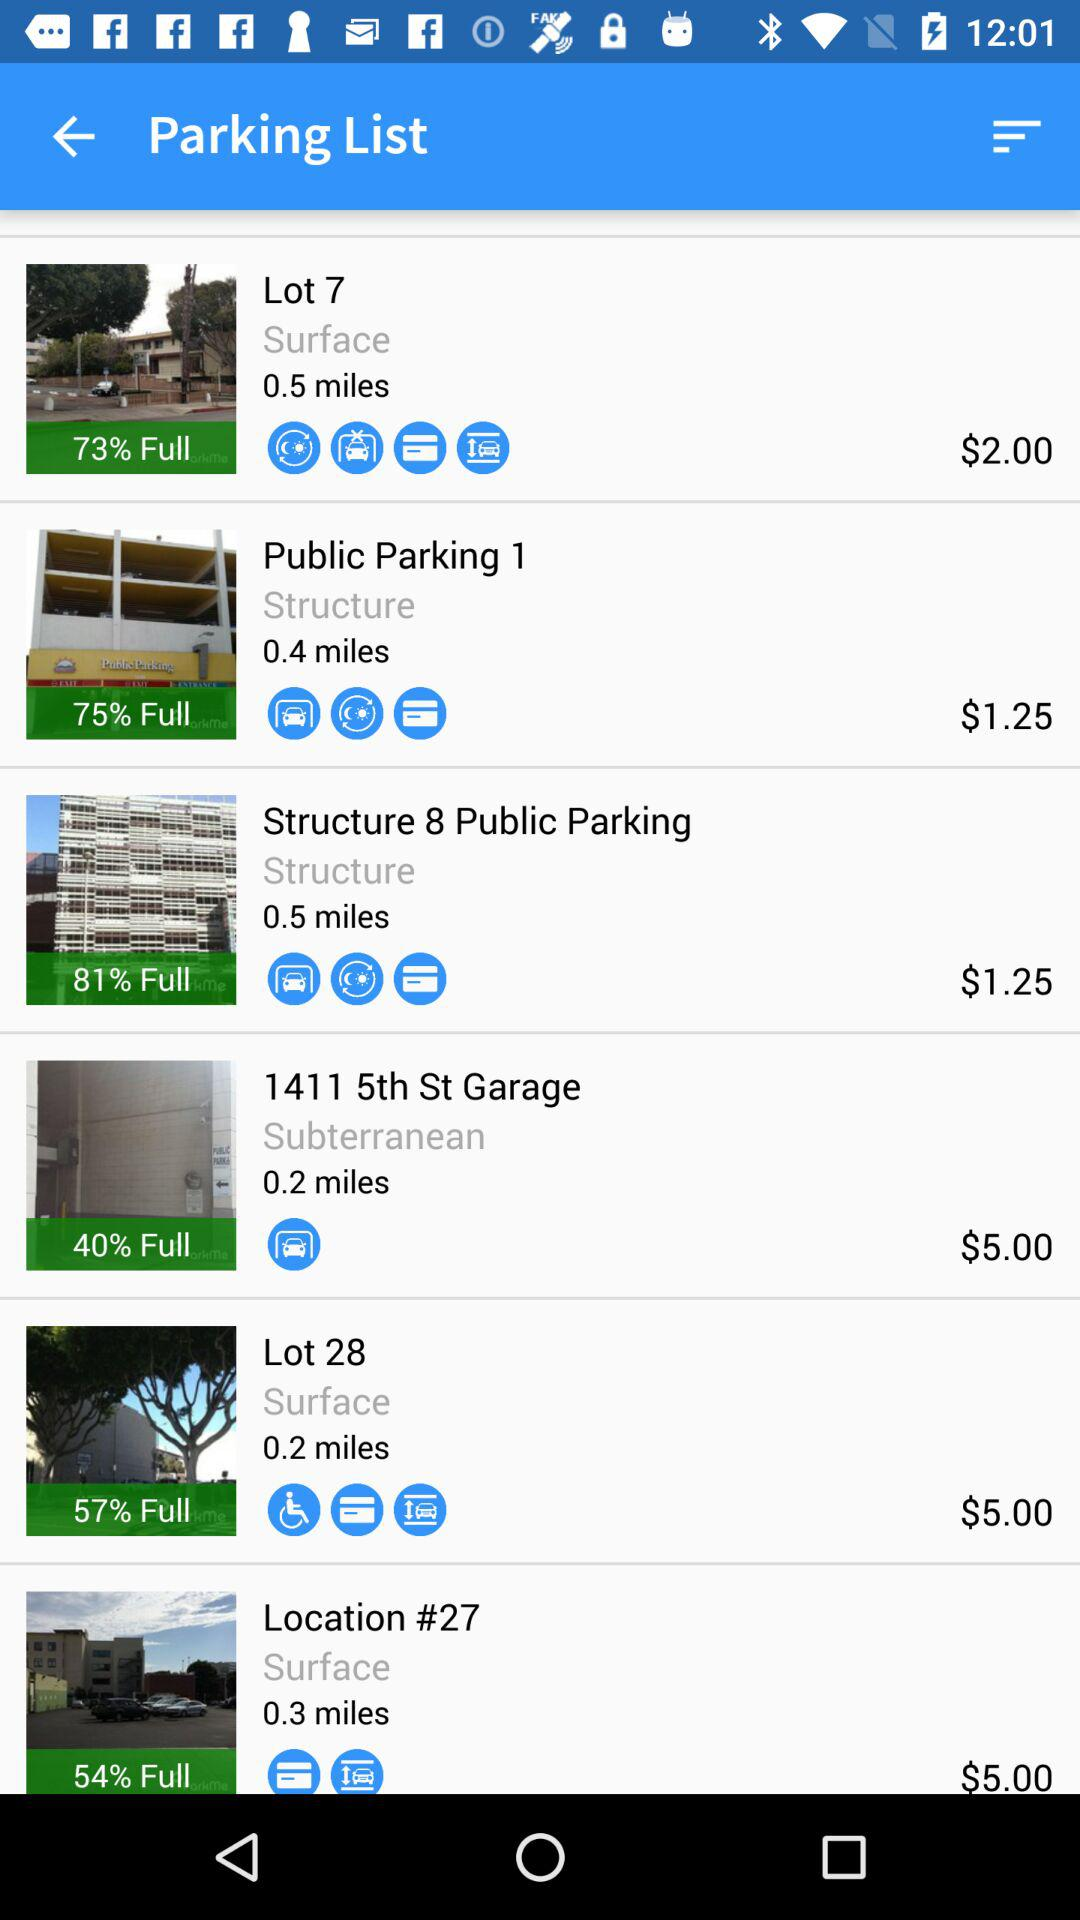How far away is Structure 8 Public Parking? Structure 8 Public Parking is 0.5 miles away. 